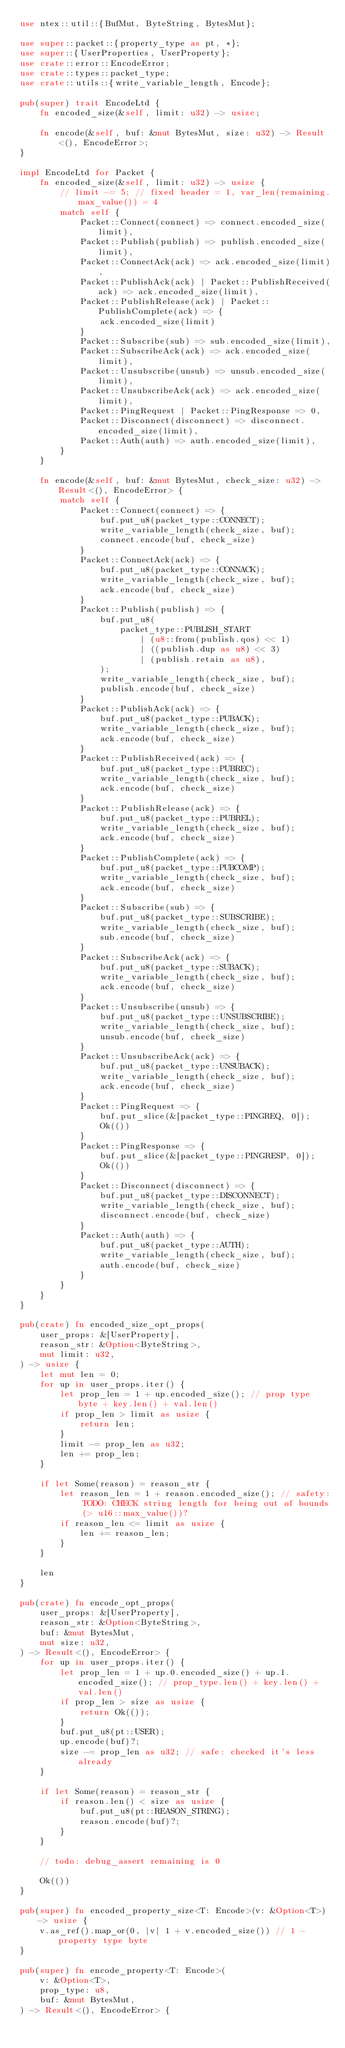Convert code to text. <code><loc_0><loc_0><loc_500><loc_500><_Rust_>use ntex::util::{BufMut, ByteString, BytesMut};

use super::packet::{property_type as pt, *};
use super::{UserProperties, UserProperty};
use crate::error::EncodeError;
use crate::types::packet_type;
use crate::utils::{write_variable_length, Encode};

pub(super) trait EncodeLtd {
    fn encoded_size(&self, limit: u32) -> usize;

    fn encode(&self, buf: &mut BytesMut, size: u32) -> Result<(), EncodeError>;
}

impl EncodeLtd for Packet {
    fn encoded_size(&self, limit: u32) -> usize {
        // limit -= 5; // fixed header = 1, var_len(remaining.max_value()) = 4
        match self {
            Packet::Connect(connect) => connect.encoded_size(limit),
            Packet::Publish(publish) => publish.encoded_size(limit),
            Packet::ConnectAck(ack) => ack.encoded_size(limit),
            Packet::PublishAck(ack) | Packet::PublishReceived(ack) => ack.encoded_size(limit),
            Packet::PublishRelease(ack) | Packet::PublishComplete(ack) => {
                ack.encoded_size(limit)
            }
            Packet::Subscribe(sub) => sub.encoded_size(limit),
            Packet::SubscribeAck(ack) => ack.encoded_size(limit),
            Packet::Unsubscribe(unsub) => unsub.encoded_size(limit),
            Packet::UnsubscribeAck(ack) => ack.encoded_size(limit),
            Packet::PingRequest | Packet::PingResponse => 0,
            Packet::Disconnect(disconnect) => disconnect.encoded_size(limit),
            Packet::Auth(auth) => auth.encoded_size(limit),
        }
    }

    fn encode(&self, buf: &mut BytesMut, check_size: u32) -> Result<(), EncodeError> {
        match self {
            Packet::Connect(connect) => {
                buf.put_u8(packet_type::CONNECT);
                write_variable_length(check_size, buf);
                connect.encode(buf, check_size)
            }
            Packet::ConnectAck(ack) => {
                buf.put_u8(packet_type::CONNACK);
                write_variable_length(check_size, buf);
                ack.encode(buf, check_size)
            }
            Packet::Publish(publish) => {
                buf.put_u8(
                    packet_type::PUBLISH_START
                        | (u8::from(publish.qos) << 1)
                        | ((publish.dup as u8) << 3)
                        | (publish.retain as u8),
                );
                write_variable_length(check_size, buf);
                publish.encode(buf, check_size)
            }
            Packet::PublishAck(ack) => {
                buf.put_u8(packet_type::PUBACK);
                write_variable_length(check_size, buf);
                ack.encode(buf, check_size)
            }
            Packet::PublishReceived(ack) => {
                buf.put_u8(packet_type::PUBREC);
                write_variable_length(check_size, buf);
                ack.encode(buf, check_size)
            }
            Packet::PublishRelease(ack) => {
                buf.put_u8(packet_type::PUBREL);
                write_variable_length(check_size, buf);
                ack.encode(buf, check_size)
            }
            Packet::PublishComplete(ack) => {
                buf.put_u8(packet_type::PUBCOMP);
                write_variable_length(check_size, buf);
                ack.encode(buf, check_size)
            }
            Packet::Subscribe(sub) => {
                buf.put_u8(packet_type::SUBSCRIBE);
                write_variable_length(check_size, buf);
                sub.encode(buf, check_size)
            }
            Packet::SubscribeAck(ack) => {
                buf.put_u8(packet_type::SUBACK);
                write_variable_length(check_size, buf);
                ack.encode(buf, check_size)
            }
            Packet::Unsubscribe(unsub) => {
                buf.put_u8(packet_type::UNSUBSCRIBE);
                write_variable_length(check_size, buf);
                unsub.encode(buf, check_size)
            }
            Packet::UnsubscribeAck(ack) => {
                buf.put_u8(packet_type::UNSUBACK);
                write_variable_length(check_size, buf);
                ack.encode(buf, check_size)
            }
            Packet::PingRequest => {
                buf.put_slice(&[packet_type::PINGREQ, 0]);
                Ok(())
            }
            Packet::PingResponse => {
                buf.put_slice(&[packet_type::PINGRESP, 0]);
                Ok(())
            }
            Packet::Disconnect(disconnect) => {
                buf.put_u8(packet_type::DISCONNECT);
                write_variable_length(check_size, buf);
                disconnect.encode(buf, check_size)
            }
            Packet::Auth(auth) => {
                buf.put_u8(packet_type::AUTH);
                write_variable_length(check_size, buf);
                auth.encode(buf, check_size)
            }
        }
    }
}

pub(crate) fn encoded_size_opt_props(
    user_props: &[UserProperty],
    reason_str: &Option<ByteString>,
    mut limit: u32,
) -> usize {
    let mut len = 0;
    for up in user_props.iter() {
        let prop_len = 1 + up.encoded_size(); // prop type byte + key.len() + val.len()
        if prop_len > limit as usize {
            return len;
        }
        limit -= prop_len as u32;
        len += prop_len;
    }

    if let Some(reason) = reason_str {
        let reason_len = 1 + reason.encoded_size(); // safety: TODO: CHECK string length for being out of bounds (> u16::max_value())?
        if reason_len <= limit as usize {
            len += reason_len;
        }
    }

    len
}

pub(crate) fn encode_opt_props(
    user_props: &[UserProperty],
    reason_str: &Option<ByteString>,
    buf: &mut BytesMut,
    mut size: u32,
) -> Result<(), EncodeError> {
    for up in user_props.iter() {
        let prop_len = 1 + up.0.encoded_size() + up.1.encoded_size(); // prop_type.len() + key.len() + val.len()
        if prop_len > size as usize {
            return Ok(());
        }
        buf.put_u8(pt::USER);
        up.encode(buf)?;
        size -= prop_len as u32; // safe: checked it's less already
    }

    if let Some(reason) = reason_str {
        if reason.len() < size as usize {
            buf.put_u8(pt::REASON_STRING);
            reason.encode(buf)?;
        }
    }

    // todo: debug_assert remaining is 0

    Ok(())
}

pub(super) fn encoded_property_size<T: Encode>(v: &Option<T>) -> usize {
    v.as_ref().map_or(0, |v| 1 + v.encoded_size()) // 1 - property type byte
}

pub(super) fn encode_property<T: Encode>(
    v: &Option<T>,
    prop_type: u8,
    buf: &mut BytesMut,
) -> Result<(), EncodeError> {</code> 